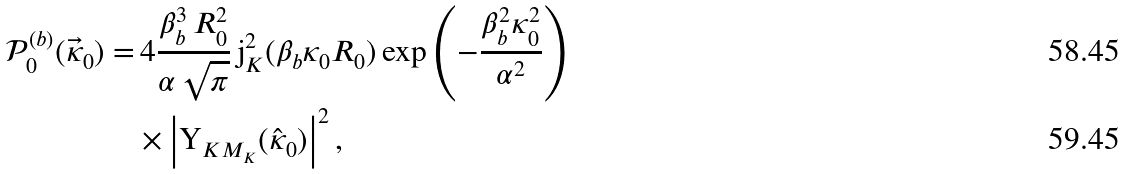Convert formula to latex. <formula><loc_0><loc_0><loc_500><loc_500>\mathcal { P } _ { 0 } ^ { ( b ) } ( \vec { \kappa } _ { 0 } ) = & \, 4 \frac { \beta _ { b } ^ { 3 } \, R _ { 0 } ^ { 2 } } { \alpha \, \sqrt { \pi } } \, \text {j} _ { K } ^ { 2 } ( \beta _ { b } \kappa _ { 0 } R _ { 0 } ) \exp \left ( - \frac { \beta _ { b } ^ { 2 } \kappa _ { 0 } ^ { 2 } } { \alpha ^ { 2 } } \right ) \\ & \times \left | \text {Y} _ { K M _ { K } } ( \hat { \kappa } _ { 0 } ) \right | ^ { 2 } ,</formula> 